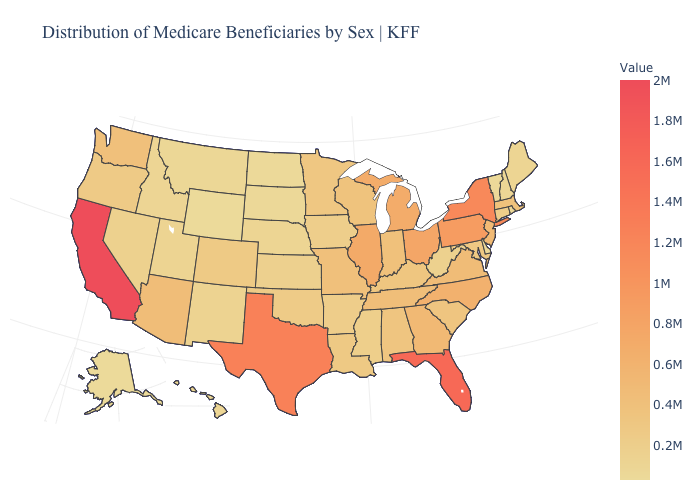Does California have the highest value in the USA?
Write a very short answer. Yes. Does North Dakota have the lowest value in the MidWest?
Be succinct. Yes. Among the states that border Montana , which have the lowest value?
Keep it brief. Wyoming. Which states have the lowest value in the USA?
Short answer required. Alaska. Among the states that border Florida , which have the highest value?
Concise answer only. Georgia. Does Alaska have the lowest value in the USA?
Concise answer only. Yes. Is the legend a continuous bar?
Short answer required. Yes. 